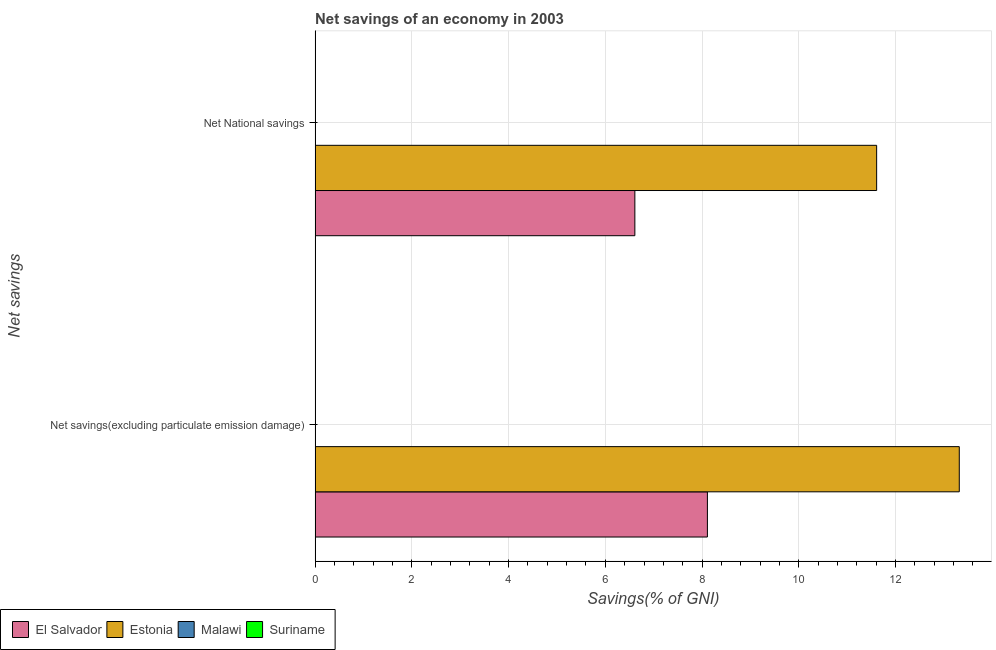How many different coloured bars are there?
Offer a terse response. 2. Are the number of bars per tick equal to the number of legend labels?
Your response must be concise. No. What is the label of the 2nd group of bars from the top?
Give a very brief answer. Net savings(excluding particulate emission damage). What is the net national savings in Malawi?
Your response must be concise. 0. Across all countries, what is the maximum net savings(excluding particulate emission damage)?
Offer a terse response. 13.32. In which country was the net savings(excluding particulate emission damage) maximum?
Offer a very short reply. Estonia. What is the total net savings(excluding particulate emission damage) in the graph?
Your answer should be compact. 21.43. What is the difference between the net savings(excluding particulate emission damage) in Estonia and that in El Salvador?
Your response must be concise. 5.21. What is the difference between the net savings(excluding particulate emission damage) in Estonia and the net national savings in Malawi?
Ensure brevity in your answer.  13.32. What is the average net national savings per country?
Provide a succinct answer. 4.56. What is the difference between the net savings(excluding particulate emission damage) and net national savings in Estonia?
Make the answer very short. 1.71. In how many countries, is the net national savings greater than 10.8 %?
Provide a succinct answer. 1. In how many countries, is the net savings(excluding particulate emission damage) greater than the average net savings(excluding particulate emission damage) taken over all countries?
Your answer should be compact. 2. Are all the bars in the graph horizontal?
Keep it short and to the point. Yes. How many countries are there in the graph?
Your answer should be compact. 4. What is the difference between two consecutive major ticks on the X-axis?
Give a very brief answer. 2. Are the values on the major ticks of X-axis written in scientific E-notation?
Keep it short and to the point. No. Does the graph contain any zero values?
Offer a terse response. Yes. Does the graph contain grids?
Keep it short and to the point. Yes. Where does the legend appear in the graph?
Provide a short and direct response. Bottom left. How many legend labels are there?
Keep it short and to the point. 4. How are the legend labels stacked?
Provide a succinct answer. Horizontal. What is the title of the graph?
Provide a short and direct response. Net savings of an economy in 2003. Does "San Marino" appear as one of the legend labels in the graph?
Your answer should be very brief. No. What is the label or title of the X-axis?
Your response must be concise. Savings(% of GNI). What is the label or title of the Y-axis?
Keep it short and to the point. Net savings. What is the Savings(% of GNI) in El Salvador in Net savings(excluding particulate emission damage)?
Keep it short and to the point. 8.11. What is the Savings(% of GNI) in Estonia in Net savings(excluding particulate emission damage)?
Provide a succinct answer. 13.32. What is the Savings(% of GNI) of El Salvador in Net National savings?
Keep it short and to the point. 6.61. What is the Savings(% of GNI) in Estonia in Net National savings?
Ensure brevity in your answer.  11.61. Across all Net savings, what is the maximum Savings(% of GNI) of El Salvador?
Your answer should be very brief. 8.11. Across all Net savings, what is the maximum Savings(% of GNI) in Estonia?
Offer a very short reply. 13.32. Across all Net savings, what is the minimum Savings(% of GNI) of El Salvador?
Your answer should be very brief. 6.61. Across all Net savings, what is the minimum Savings(% of GNI) of Estonia?
Your answer should be compact. 11.61. What is the total Savings(% of GNI) of El Salvador in the graph?
Your response must be concise. 14.72. What is the total Savings(% of GNI) of Estonia in the graph?
Your answer should be compact. 24.93. What is the difference between the Savings(% of GNI) of El Salvador in Net savings(excluding particulate emission damage) and that in Net National savings?
Your answer should be compact. 1.5. What is the difference between the Savings(% of GNI) of Estonia in Net savings(excluding particulate emission damage) and that in Net National savings?
Provide a succinct answer. 1.71. What is the difference between the Savings(% of GNI) of El Salvador in Net savings(excluding particulate emission damage) and the Savings(% of GNI) of Estonia in Net National savings?
Keep it short and to the point. -3.5. What is the average Savings(% of GNI) of El Salvador per Net savings?
Offer a very short reply. 7.36. What is the average Savings(% of GNI) of Estonia per Net savings?
Your answer should be compact. 12.46. What is the average Savings(% of GNI) in Malawi per Net savings?
Keep it short and to the point. 0. What is the difference between the Savings(% of GNI) in El Salvador and Savings(% of GNI) in Estonia in Net savings(excluding particulate emission damage)?
Provide a succinct answer. -5.21. What is the difference between the Savings(% of GNI) in El Salvador and Savings(% of GNI) in Estonia in Net National savings?
Give a very brief answer. -5. What is the ratio of the Savings(% of GNI) of El Salvador in Net savings(excluding particulate emission damage) to that in Net National savings?
Provide a short and direct response. 1.23. What is the ratio of the Savings(% of GNI) of Estonia in Net savings(excluding particulate emission damage) to that in Net National savings?
Offer a very short reply. 1.15. What is the difference between the highest and the second highest Savings(% of GNI) of El Salvador?
Make the answer very short. 1.5. What is the difference between the highest and the second highest Savings(% of GNI) of Estonia?
Offer a very short reply. 1.71. What is the difference between the highest and the lowest Savings(% of GNI) in El Salvador?
Your answer should be very brief. 1.5. What is the difference between the highest and the lowest Savings(% of GNI) in Estonia?
Give a very brief answer. 1.71. 